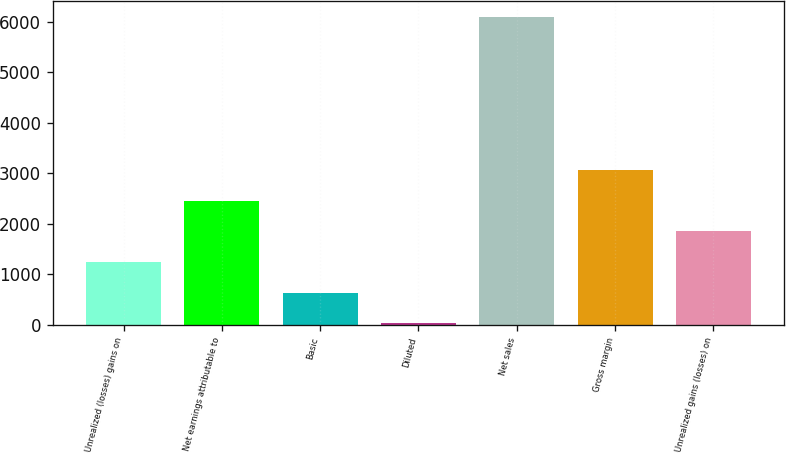Convert chart to OTSL. <chart><loc_0><loc_0><loc_500><loc_500><bar_chart><fcel>Unrealized (losses) gains on<fcel>Net earnings attributable to<fcel>Basic<fcel>Diluted<fcel>Net sales<fcel>Gross margin<fcel>Unrealized gains (losses) on<nl><fcel>1242.45<fcel>2456.31<fcel>635.52<fcel>28.59<fcel>6097.9<fcel>3063.24<fcel>1849.38<nl></chart> 